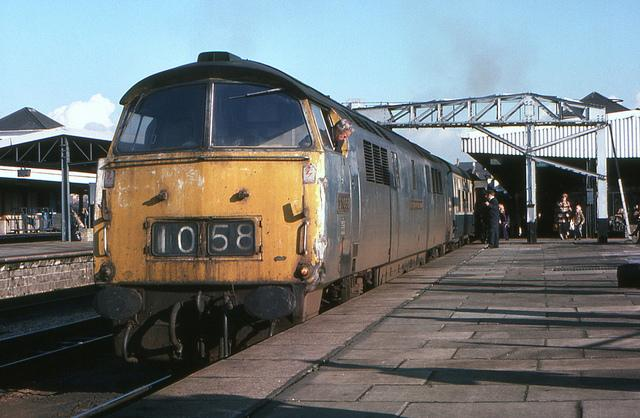What metro train number is this?

Choices:
A) 8501
B) 1058
C) 5810
D) 8051 1058 